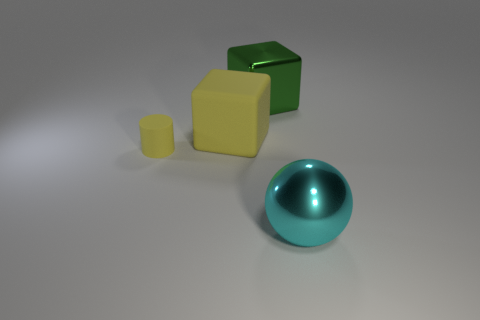How many yellow matte cylinders are the same size as the cyan object?
Your response must be concise. 0. What material is the other large thing that is the same shape as the green object?
Ensure brevity in your answer.  Rubber. What is the color of the matte cube that is on the right side of the yellow cylinder?
Offer a very short reply. Yellow. Are there more large objects on the left side of the rubber cube than green things?
Provide a short and direct response. No. The small rubber thing has what color?
Your response must be concise. Yellow. There is a large metallic object in front of the metal thing to the left of the metallic thing to the right of the green block; what is its shape?
Offer a terse response. Sphere. The thing that is on the right side of the small yellow matte cylinder and left of the green metal thing is made of what material?
Provide a succinct answer. Rubber. What is the shape of the yellow thing in front of the large thing that is to the left of the big green shiny object?
Keep it short and to the point. Cylinder. Is there anything else that has the same color as the small matte cylinder?
Give a very brief answer. Yes. There is a green metallic block; is it the same size as the metallic thing that is on the right side of the big green block?
Offer a very short reply. Yes. 